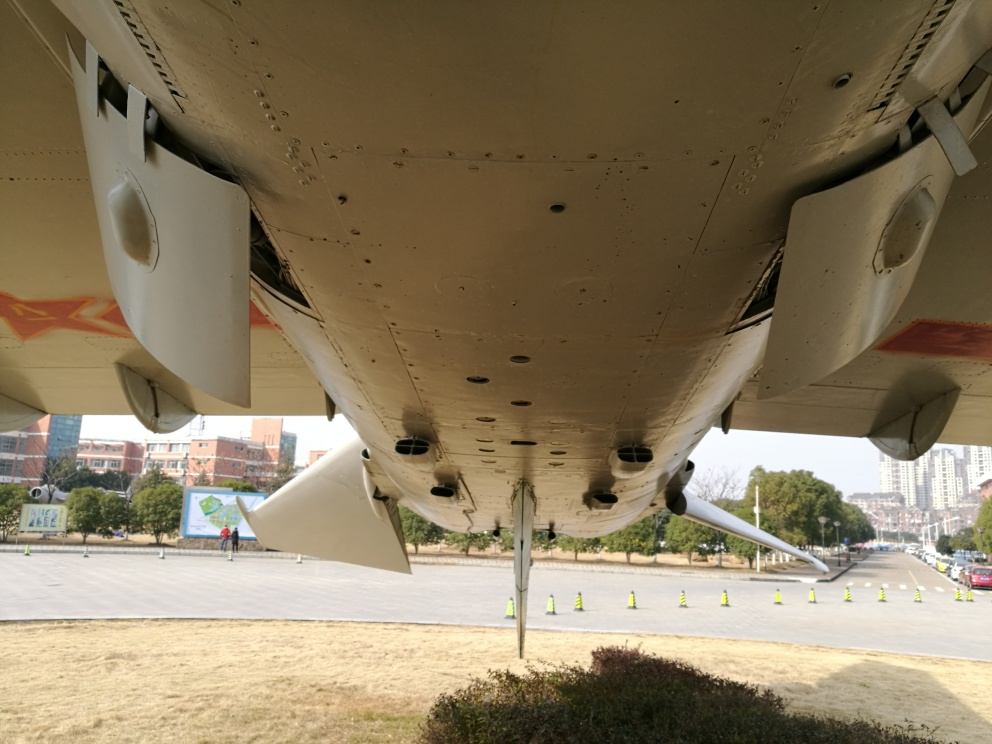Can you describe the setting where this aircraft is located? The aircraft is situated in an outdoor environment, likely within an aviation museum or a similar exhibit given the way it is displayed. It is resting on a paved surface, and there are visible barriers and indications that the area is organized for visitors. The surrounding area includes trees and buildings that suggest an urban or semi-urban park setting. 